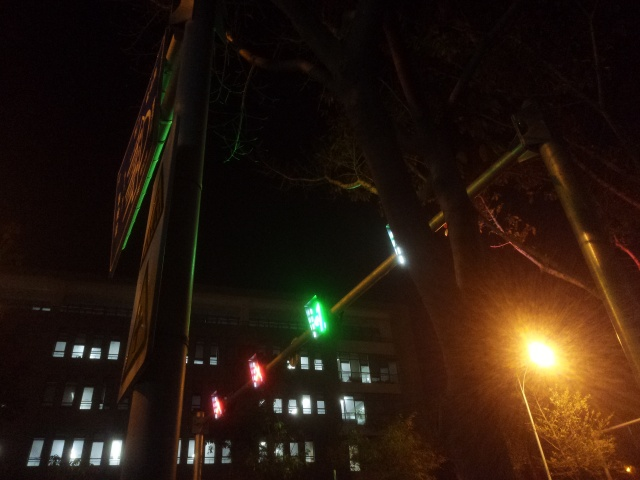What time of day does this image seem to represent? Based on the darkness in the image and artificial lighting evident, it suggests nighttime. Street and traffic lights are visible, which are typically more prominent and necessary after the sun has set. 